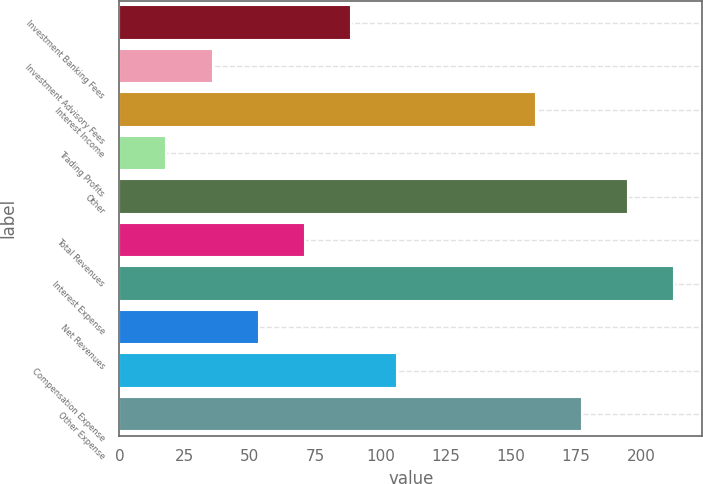<chart> <loc_0><loc_0><loc_500><loc_500><bar_chart><fcel>Investment Banking Fees<fcel>Investment Advisory Fees<fcel>Interest Income<fcel>Trading Profits<fcel>Other<fcel>Total Revenues<fcel>Interest Expense<fcel>Net Revenues<fcel>Compensation Expense<fcel>Other Expense<nl><fcel>88.8<fcel>35.7<fcel>159.6<fcel>18<fcel>195<fcel>71.1<fcel>212.7<fcel>53.4<fcel>106.5<fcel>177.3<nl></chart> 